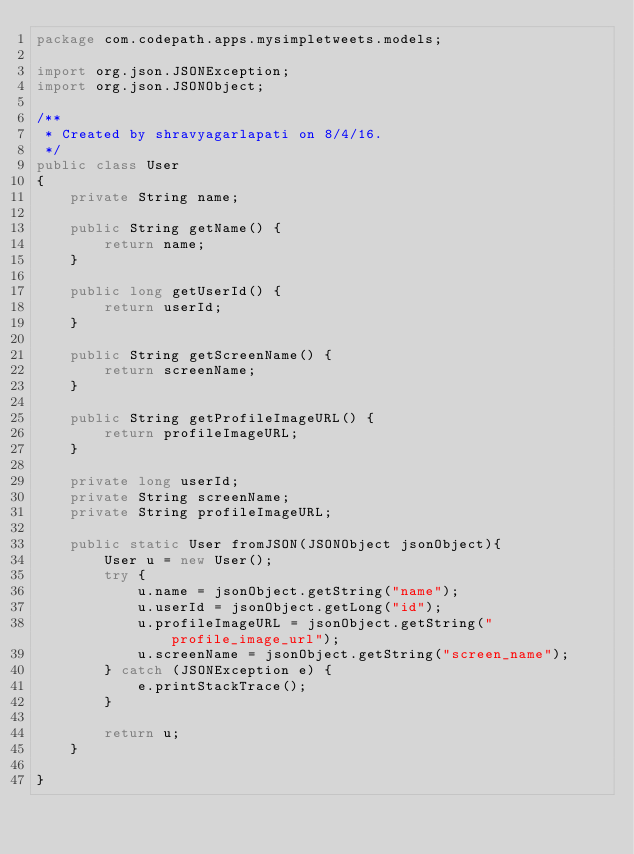Convert code to text. <code><loc_0><loc_0><loc_500><loc_500><_Java_>package com.codepath.apps.mysimpletweets.models;

import org.json.JSONException;
import org.json.JSONObject;

/**
 * Created by shravyagarlapati on 8/4/16.
 */
public class User
{
    private String name;

    public String getName() {
        return name;
    }

    public long getUserId() {
        return userId;
    }

    public String getScreenName() {
        return screenName;
    }

    public String getProfileImageURL() {
        return profileImageURL;
    }

    private long userId;
    private String screenName;
    private String profileImageURL;

    public static User fromJSON(JSONObject jsonObject){
        User u = new User();
        try {
            u.name = jsonObject.getString("name");
            u.userId = jsonObject.getLong("id");
            u.profileImageURL = jsonObject.getString("profile_image_url");
            u.screenName = jsonObject.getString("screen_name");
        } catch (JSONException e) {
            e.printStackTrace();
        }

        return u;
    }

}
</code> 